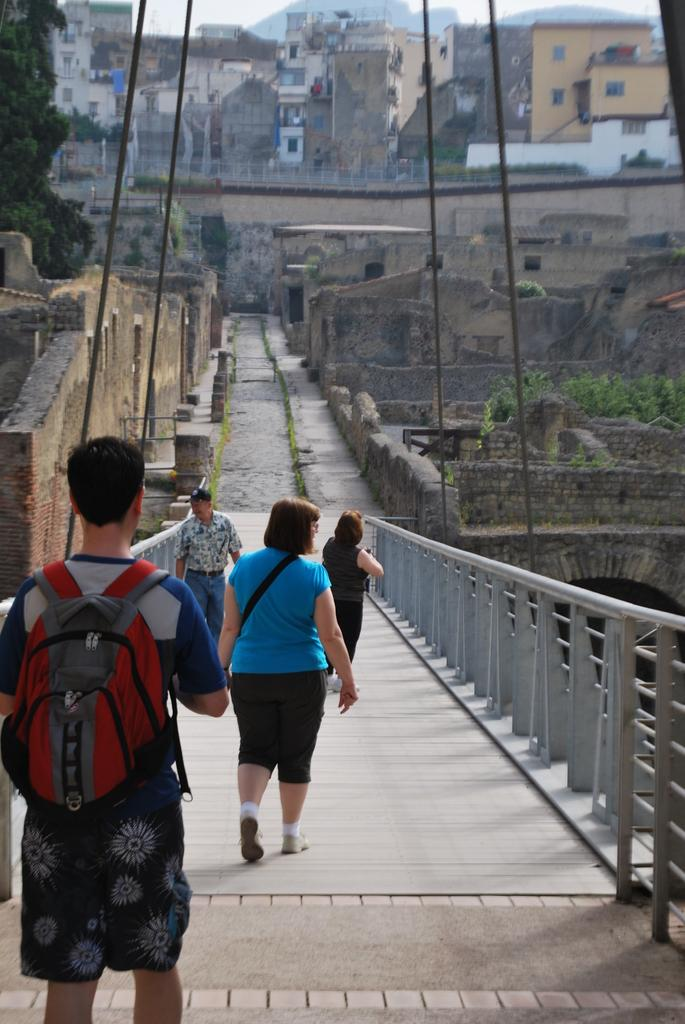Who or what can be seen in the image? There are people in the image. What are the people doing in the image? The people are walking across a bridge. What type of baseball game is being played on the bridge in the image? There is no baseball game present in the image; it features people walking across a bridge. What time does the clock on the bridge indicate in the image? There is no clock visible in the image. 